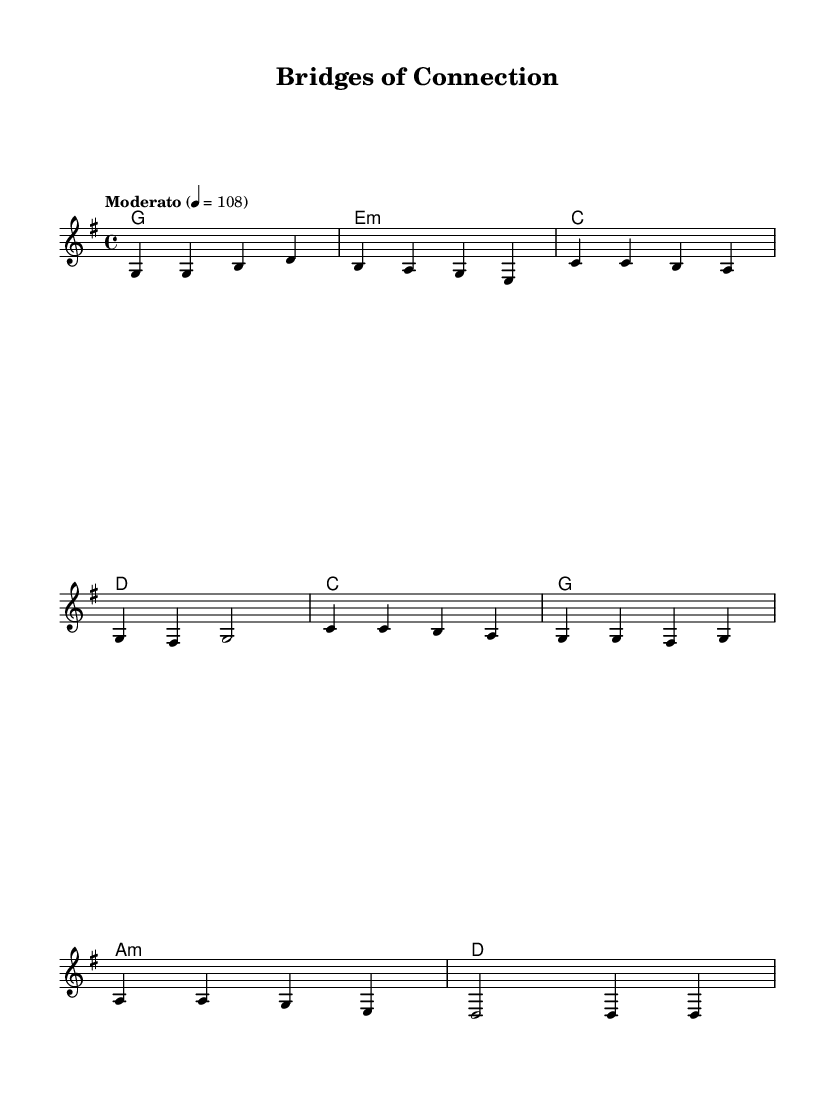What is the key signature of this music? The music is in G major, which has one sharp (F#). You can determine this by looking at the key signature indicated at the beginning of the score.
Answer: G major What is the time signature of this music? The time signature is 4/4, which indicates there are four beats per measure. This is typically found at the beginning of the score next to the key signature.
Answer: 4/4 What is the tempo marking for this piece? The tempo marking is "Moderato," and the number indicates the beats per minute, which is 108. This is shown in the score above the treble staff.
Answer: Moderato How many measures are in the verse section? The verse section consists of 4 measures, as indicated by the grouping of notes and the counting of the measures shown in the music.
Answer: 4 What type of chords are present in the verse section? The chords in the verse section are G major, E minor, C major, and D major; these are typical chords found in folk music and create a harmonious backdrop for the melody.
Answer: G, E minor, C, D What is the central theme of the lyrics in the chorus? The central theme revolves around networking as a key to unlocking opportunities; this can be understood by analyzing the lyrical content that emphasizes the importance of relationships.
Answer: Networking key What is the main musical structure of this piece? The main structure follows a verse-chorus form, which is a common layout in folk music where verses provide narrative and choruses deliver the thematic essence.
Answer: Verse-Chorus 